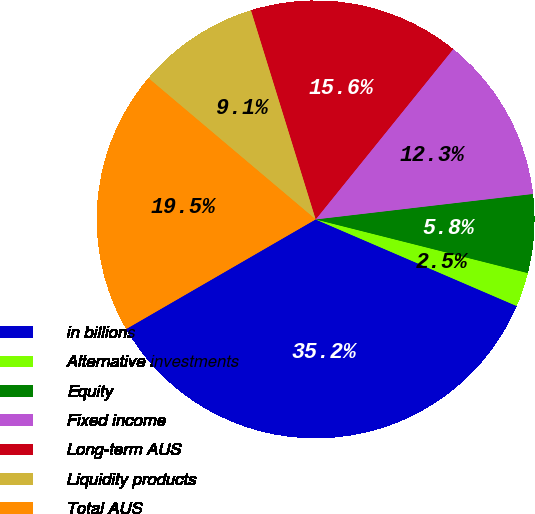Convert chart to OTSL. <chart><loc_0><loc_0><loc_500><loc_500><pie_chart><fcel>in billions<fcel>Alternative investments<fcel>Equity<fcel>Fixed income<fcel>Long-term AUS<fcel>Liquidity products<fcel>Total AUS<nl><fcel>35.18%<fcel>2.53%<fcel>5.8%<fcel>12.33%<fcel>15.59%<fcel>9.06%<fcel>19.51%<nl></chart> 